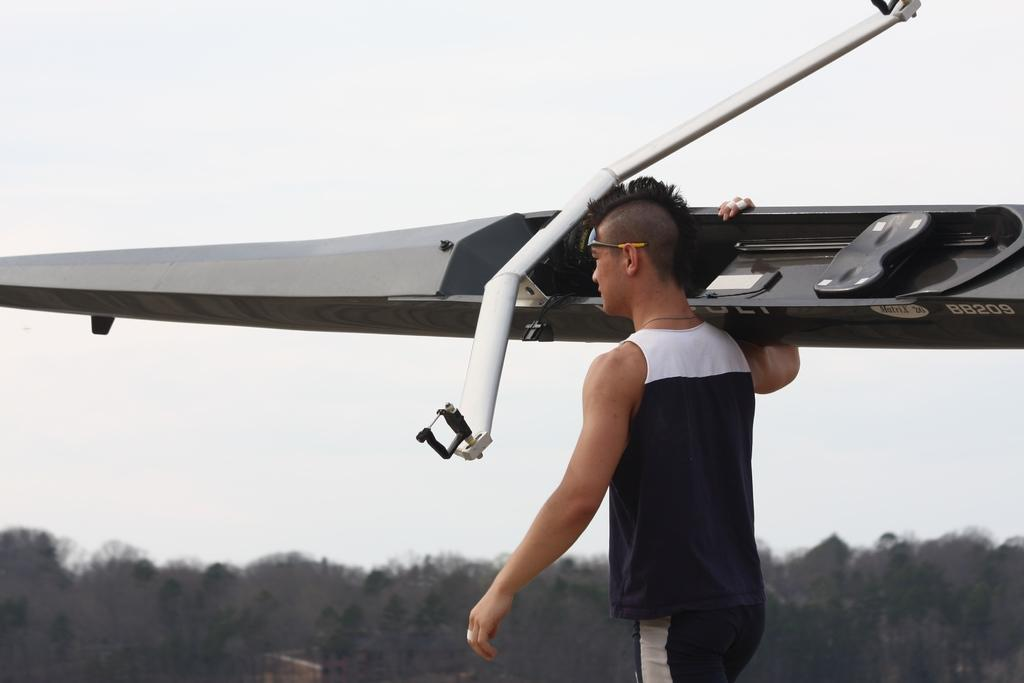<image>
Present a compact description of the photo's key features. A man with a mow hawk carrying a watercraft labeled BB203 on his shoulder. 